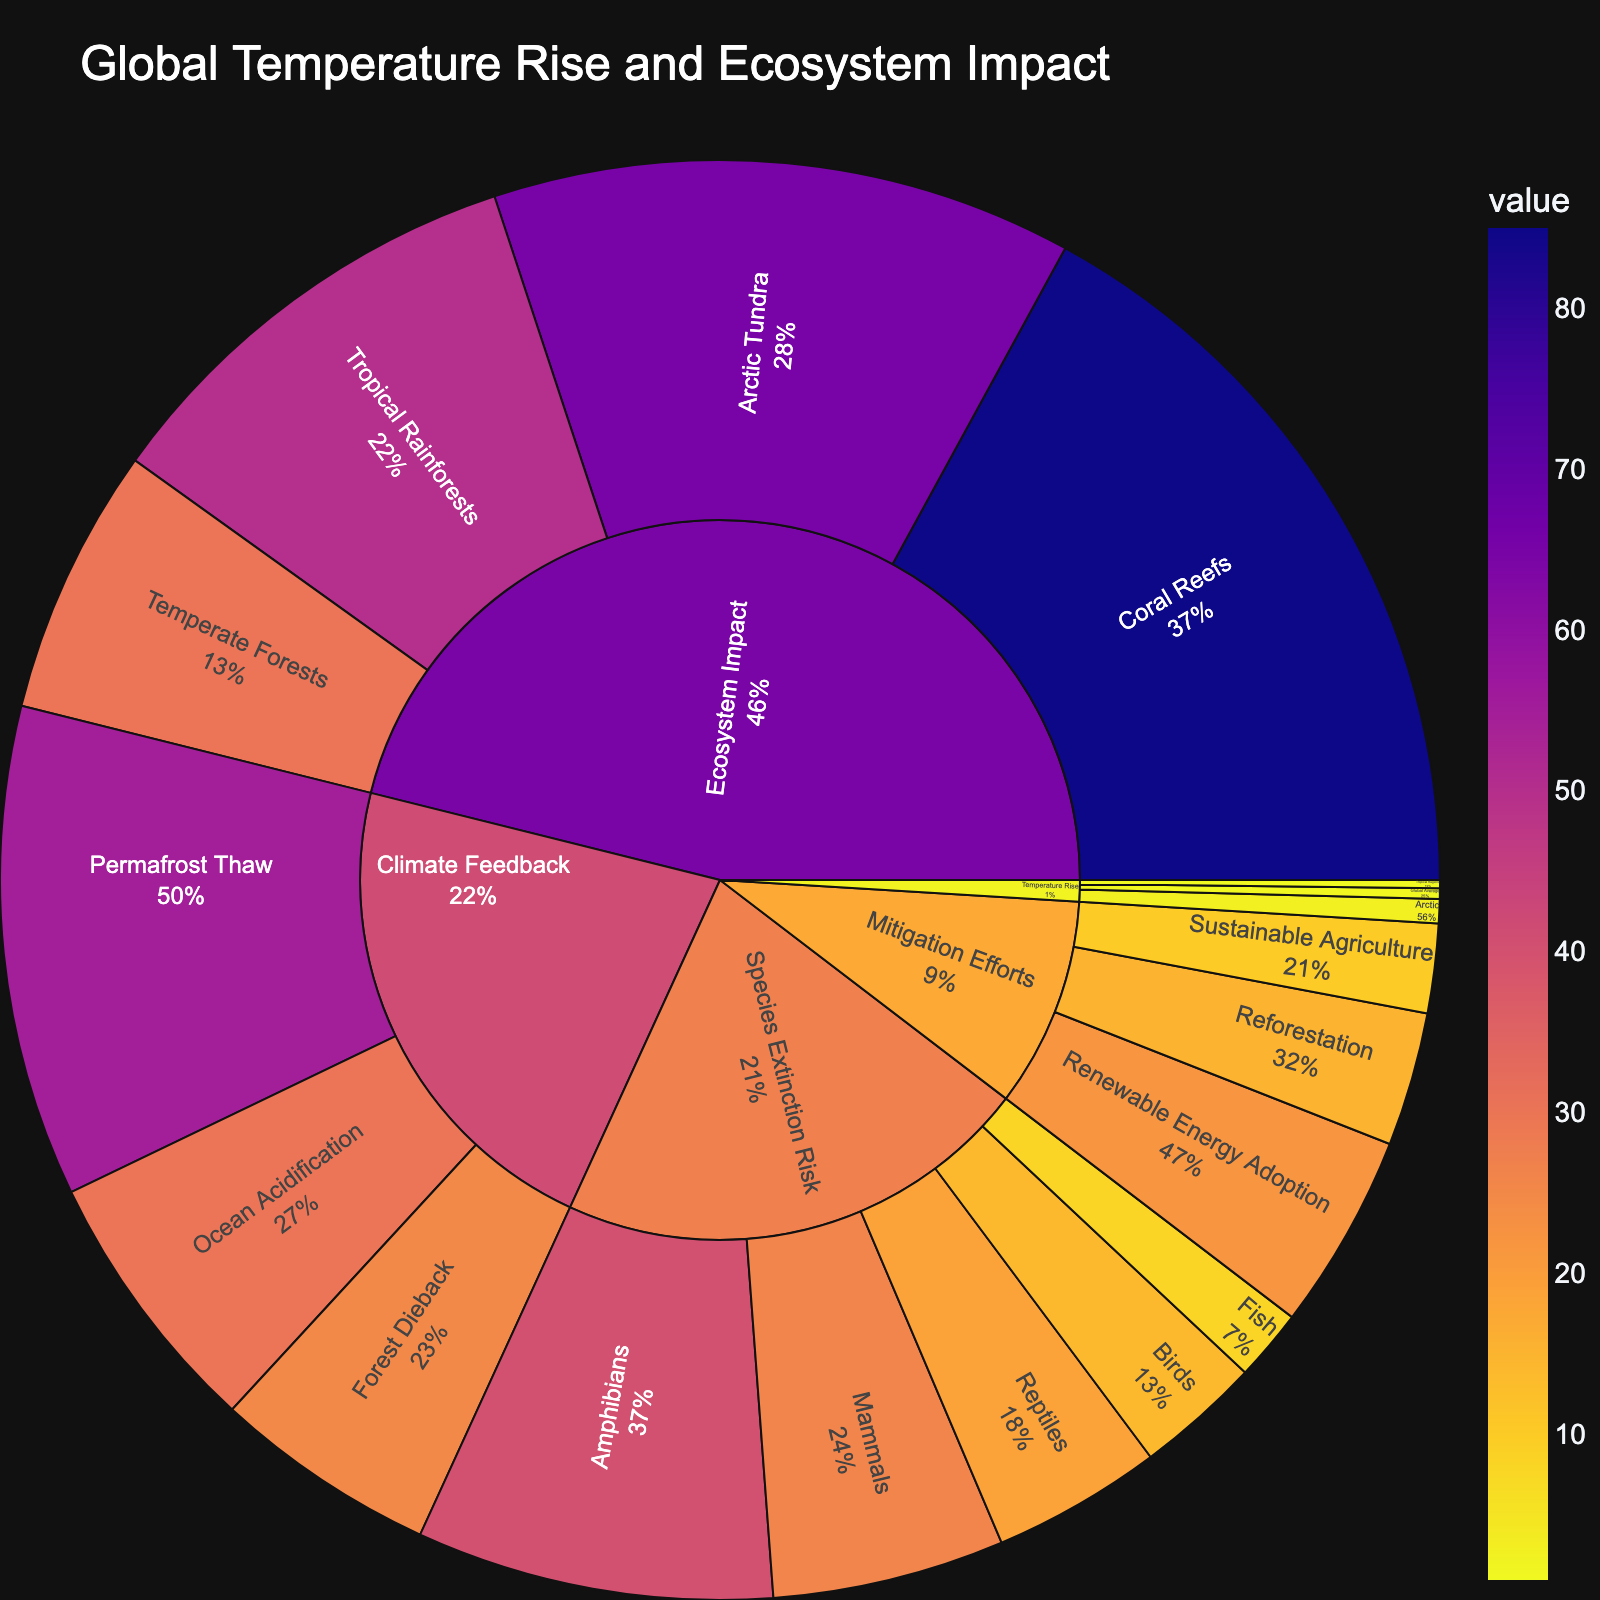what is the value associated with global average temperature rise? The value can be found directly under the Global Average subcategory of Temperature Rise in the sunburst plot.
Answer: 1.2 which ecosystem has the highest impact due to temperature rise? Find the subcategory with the largest value under the Ecosystem Impact category in the sunburst plot. Coral Reefs have the highest value.
Answer: Coral Reefs what is the total value of species extinction risk for all species combined? Sum the values for Amphibians, Mammals, Birds, Reptiles, and Fish. This is 40 + 26 + 14 + 19 + 8 = 107.
Answer: 107 how does the impact on arctic tundra compare with tropical rainforests? Compare the values listed under the Ecosystem Impact category for Arctic Tundra and Tropical Rainforests. Arctic Tundra has a value of 65, which is greater than Tropical Rainforests' value of 50.
Answer: Arctic Tundra has a greater impact (65 vs. 50) which climate feedback has the highest value? Look under the Climate Feedback category for the subcategory with the highest value. Permafrost Thaw has the highest value at 55.
Answer: Permafrost Thaw what is the combined impact value of mitigation efforts? Sum the values for Renewable Energy Adoption, Reforestation, and Sustainable Agriculture. This is 22 + 15 + 10 = 47.
Answer: 47 which temperature rise region has the lowest value, and what is it? Compare the values under Temperature Rise. Tropical Regions have the lowest value at 0.9.
Answer: Tropical Regions, 0.9 what percentage of the total ecosystem impact comes from temperate forests? Calculate the percentage by dividing the value of Temperate Forests by the sum of all values under Ecosystem Impact and multiplying by 100. For Ecosystem Impact: Total = 85 + 65 + 50 + 30 = 230. So, (30/230) * 100 ≈ 13.04%.
Answer: 13.04% how does the risk of extinction for amphibians compare to the combined risk for mammals and birds? Compare the value for Amphibians with the sum of values for Mammals and Birds. Amphibians is 40; Mammals + Birds: 26 + 14 = 40. Therefore, the risk is the same.
Answer: same (40 vs. 40) which category has the most subcategories listed? Examine the number of subcategories under each main category. Species Extinction Risk has five subcategories - the most among all categories.
Answer: Species Extinction Risk 